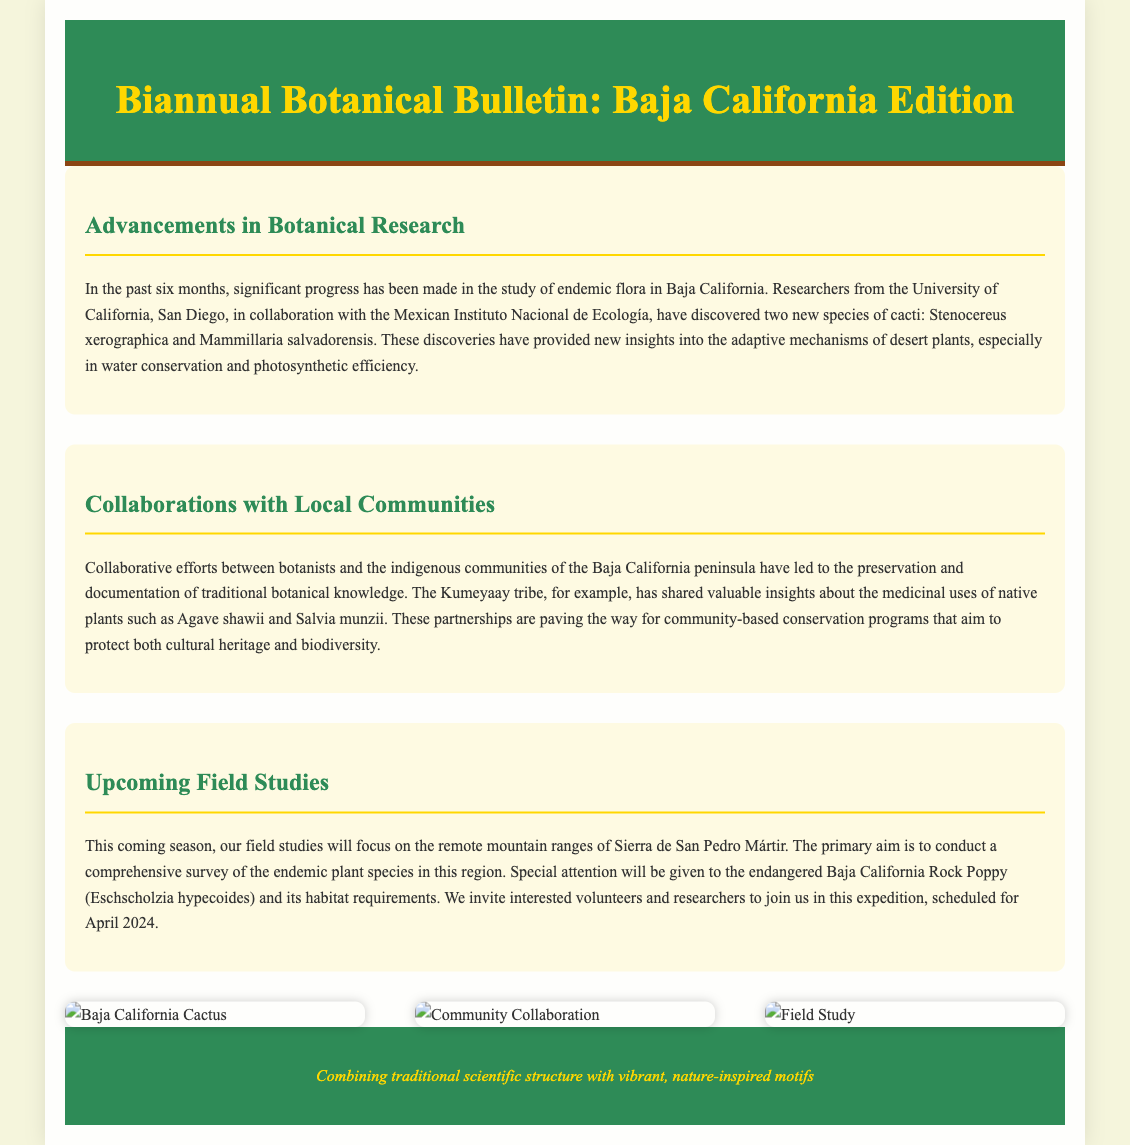what is the title of the newsletter? The title of the newsletter is presented prominently at the top of the document.
Answer: Biannual Botanical Bulletin: Baja California Edition which two new species of cacti were discovered? The document mentions two specific species of cacti that were recently discovered.
Answer: Stenocereus xerographica and Mammillaria salvadorensis which indigenous tribe collaborated with botanists? The document highlights a specific indigenous tribe that has collaborated in botanical research.
Answer: Kumeyaay what endangered plant species will be studied in the upcoming field studies? The document specifies an endangered plant species that will be a focus in the upcoming field studies.
Answer: Baja California Rock Poppy (Eschscholzia hypecoides) when is the scheduled field study expedition? The document provides a specific date for the upcoming field study expedition.
Answer: April 2024 what is the primary aim of the field studies in Sierra de San Pedro Mártir? The document outlines the main goal of the field studies planned in a particular location.
Answer: Conduct a comprehensive survey of the endemic plant species what visual elements are used in the document? The structure of the document incorporates both text and imagery to enhance the presentation.
Answer: Vibrant, nature-inspired motifs 